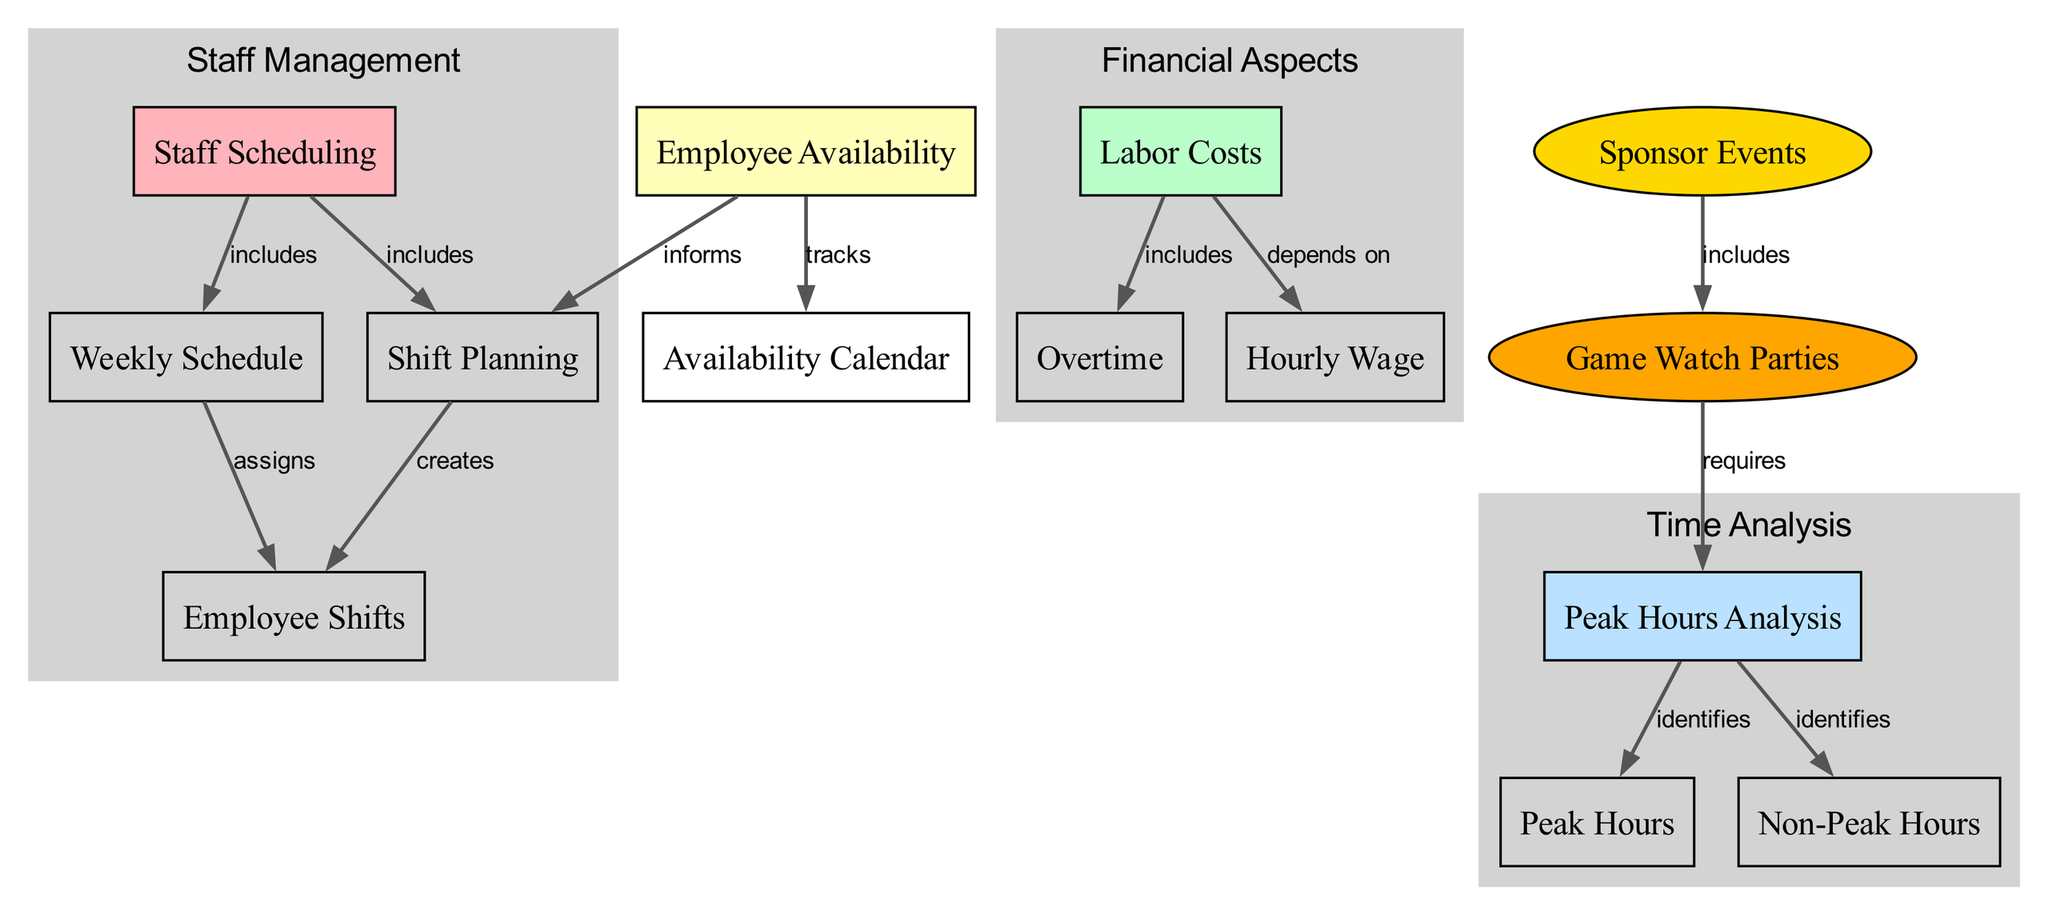What are the main components included in staff scheduling? The diagram shows that staff scheduling includes shift planning and a weekly schedule. By looking at the edges connected to the "staff_scheduling" node, both "shift_planning" and "weekly_schedule" are listed as direct connections, indicating their inclusion.
Answer: Shift planning, weekly schedule How does labor costs relate to hourly wage? The diagram indicates a direct dependency relationship between labor costs and hourly wage. Following the edge labeled "depends on" from "labor_costs" to "hourly_wage" confirms that labor costs are influenced by the hourly wage.
Answer: Depends on What does peak hours analysis identify? According to the diagram, peak hours analysis identifies both peak hours and non-peak hours. The edges from "peak_hours_analysis" node point to these two nodes, demonstrating their identification as part of this analysis.
Answer: Peak hours, non-peak hours What creates employee shifts? The diagram shows that employee shifts are created through shift planning. The connection labeled "creates" from "shift_planning" to "employee_shifts" directly states that relationship.
Answer: Shift planning How many nodes are there in the diagram? By counting each individual node present in the diagram's node list, there are 14 nodes in total, including all elements such as staff scheduling, labor costs, and more.
Answer: 14 